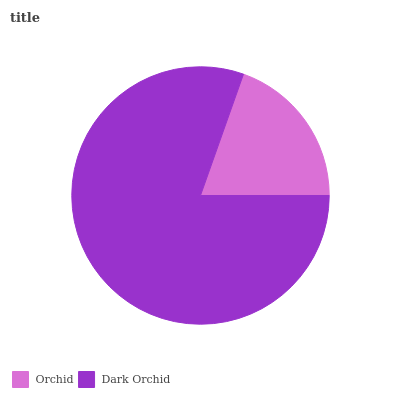Is Orchid the minimum?
Answer yes or no. Yes. Is Dark Orchid the maximum?
Answer yes or no. Yes. Is Dark Orchid the minimum?
Answer yes or no. No. Is Dark Orchid greater than Orchid?
Answer yes or no. Yes. Is Orchid less than Dark Orchid?
Answer yes or no. Yes. Is Orchid greater than Dark Orchid?
Answer yes or no. No. Is Dark Orchid less than Orchid?
Answer yes or no. No. Is Dark Orchid the high median?
Answer yes or no. Yes. Is Orchid the low median?
Answer yes or no. Yes. Is Orchid the high median?
Answer yes or no. No. Is Dark Orchid the low median?
Answer yes or no. No. 